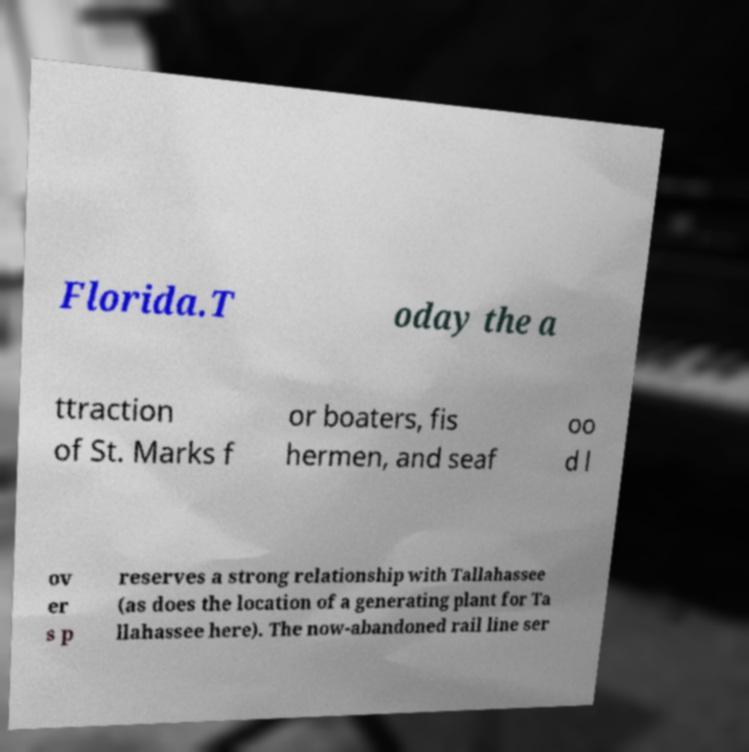I need the written content from this picture converted into text. Can you do that? Florida.T oday the a ttraction of St. Marks f or boaters, fis hermen, and seaf oo d l ov er s p reserves a strong relationship with Tallahassee (as does the location of a generating plant for Ta llahassee here). The now-abandoned rail line ser 